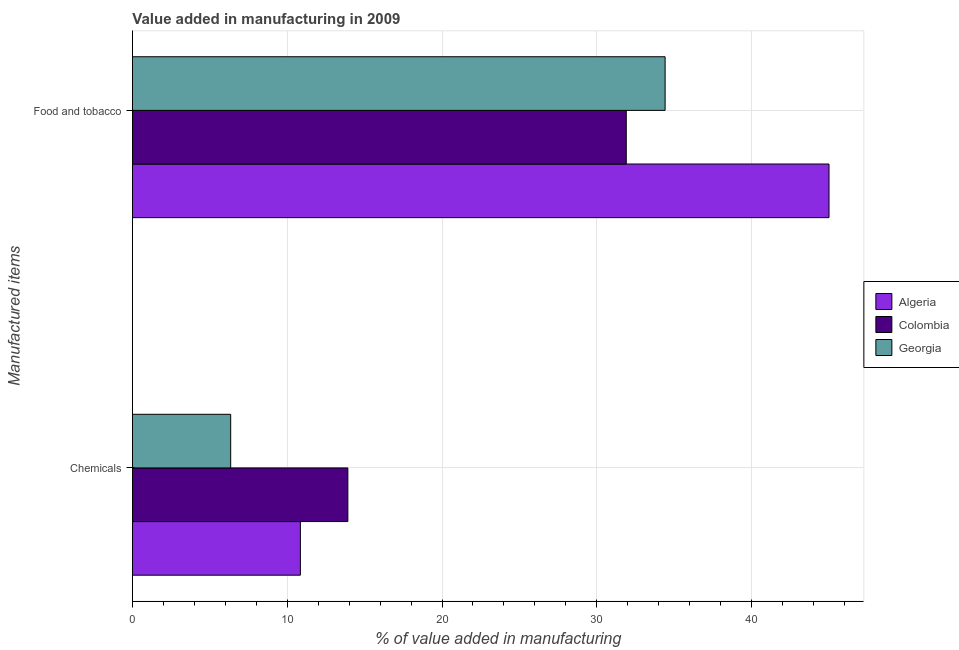How many groups of bars are there?
Keep it short and to the point. 2. Are the number of bars per tick equal to the number of legend labels?
Make the answer very short. Yes. How many bars are there on the 1st tick from the top?
Keep it short and to the point. 3. How many bars are there on the 1st tick from the bottom?
Offer a terse response. 3. What is the label of the 2nd group of bars from the top?
Your answer should be very brief. Chemicals. What is the value added by  manufacturing chemicals in Algeria?
Your response must be concise. 10.85. Across all countries, what is the maximum value added by  manufacturing chemicals?
Provide a short and direct response. 13.92. Across all countries, what is the minimum value added by  manufacturing chemicals?
Your answer should be very brief. 6.35. In which country was the value added by manufacturing food and tobacco maximum?
Your response must be concise. Algeria. What is the total value added by manufacturing food and tobacco in the graph?
Keep it short and to the point. 111.31. What is the difference between the value added by manufacturing food and tobacco in Georgia and that in Algeria?
Keep it short and to the point. -10.59. What is the difference between the value added by  manufacturing chemicals in Georgia and the value added by manufacturing food and tobacco in Algeria?
Make the answer very short. -38.65. What is the average value added by  manufacturing chemicals per country?
Offer a terse response. 10.37. What is the difference between the value added by  manufacturing chemicals and value added by manufacturing food and tobacco in Georgia?
Your answer should be compact. -28.06. In how many countries, is the value added by  manufacturing chemicals greater than 28 %?
Make the answer very short. 0. What is the ratio of the value added by  manufacturing chemicals in Georgia to that in Algeria?
Offer a terse response. 0.59. Is the value added by  manufacturing chemicals in Georgia less than that in Algeria?
Your response must be concise. Yes. What does the 1st bar from the top in Chemicals represents?
Your answer should be very brief. Georgia. What does the 1st bar from the bottom in Chemicals represents?
Offer a terse response. Algeria. How many countries are there in the graph?
Offer a very short reply. 3. Does the graph contain grids?
Your response must be concise. Yes. What is the title of the graph?
Your response must be concise. Value added in manufacturing in 2009. Does "Indonesia" appear as one of the legend labels in the graph?
Provide a succinct answer. No. What is the label or title of the X-axis?
Make the answer very short. % of value added in manufacturing. What is the label or title of the Y-axis?
Give a very brief answer. Manufactured items. What is the % of value added in manufacturing in Algeria in Chemicals?
Your answer should be compact. 10.85. What is the % of value added in manufacturing of Colombia in Chemicals?
Provide a succinct answer. 13.92. What is the % of value added in manufacturing of Georgia in Chemicals?
Keep it short and to the point. 6.35. What is the % of value added in manufacturing of Algeria in Food and tobacco?
Make the answer very short. 45. What is the % of value added in manufacturing of Colombia in Food and tobacco?
Provide a succinct answer. 31.9. What is the % of value added in manufacturing of Georgia in Food and tobacco?
Offer a very short reply. 34.41. Across all Manufactured items, what is the maximum % of value added in manufacturing in Algeria?
Provide a succinct answer. 45. Across all Manufactured items, what is the maximum % of value added in manufacturing of Colombia?
Provide a short and direct response. 31.9. Across all Manufactured items, what is the maximum % of value added in manufacturing in Georgia?
Your answer should be very brief. 34.41. Across all Manufactured items, what is the minimum % of value added in manufacturing in Algeria?
Give a very brief answer. 10.85. Across all Manufactured items, what is the minimum % of value added in manufacturing in Colombia?
Offer a very short reply. 13.92. Across all Manufactured items, what is the minimum % of value added in manufacturing in Georgia?
Make the answer very short. 6.35. What is the total % of value added in manufacturing of Algeria in the graph?
Offer a very short reply. 55.85. What is the total % of value added in manufacturing of Colombia in the graph?
Ensure brevity in your answer.  45.82. What is the total % of value added in manufacturing of Georgia in the graph?
Your answer should be very brief. 40.76. What is the difference between the % of value added in manufacturing in Algeria in Chemicals and that in Food and tobacco?
Make the answer very short. -34.15. What is the difference between the % of value added in manufacturing of Colombia in Chemicals and that in Food and tobacco?
Make the answer very short. -17.98. What is the difference between the % of value added in manufacturing of Georgia in Chemicals and that in Food and tobacco?
Keep it short and to the point. -28.06. What is the difference between the % of value added in manufacturing of Algeria in Chemicals and the % of value added in manufacturing of Colombia in Food and tobacco?
Your response must be concise. -21.05. What is the difference between the % of value added in manufacturing in Algeria in Chemicals and the % of value added in manufacturing in Georgia in Food and tobacco?
Ensure brevity in your answer.  -23.56. What is the difference between the % of value added in manufacturing in Colombia in Chemicals and the % of value added in manufacturing in Georgia in Food and tobacco?
Give a very brief answer. -20.49. What is the average % of value added in manufacturing of Algeria per Manufactured items?
Give a very brief answer. 27.92. What is the average % of value added in manufacturing of Colombia per Manufactured items?
Your answer should be compact. 22.91. What is the average % of value added in manufacturing of Georgia per Manufactured items?
Keep it short and to the point. 20.38. What is the difference between the % of value added in manufacturing in Algeria and % of value added in manufacturing in Colombia in Chemicals?
Make the answer very short. -3.07. What is the difference between the % of value added in manufacturing of Algeria and % of value added in manufacturing of Georgia in Chemicals?
Keep it short and to the point. 4.5. What is the difference between the % of value added in manufacturing of Colombia and % of value added in manufacturing of Georgia in Chemicals?
Offer a very short reply. 7.57. What is the difference between the % of value added in manufacturing of Algeria and % of value added in manufacturing of Colombia in Food and tobacco?
Your answer should be very brief. 13.1. What is the difference between the % of value added in manufacturing in Algeria and % of value added in manufacturing in Georgia in Food and tobacco?
Ensure brevity in your answer.  10.59. What is the difference between the % of value added in manufacturing in Colombia and % of value added in manufacturing in Georgia in Food and tobacco?
Your answer should be very brief. -2.51. What is the ratio of the % of value added in manufacturing in Algeria in Chemicals to that in Food and tobacco?
Your answer should be very brief. 0.24. What is the ratio of the % of value added in manufacturing in Colombia in Chemicals to that in Food and tobacco?
Provide a short and direct response. 0.44. What is the ratio of the % of value added in manufacturing of Georgia in Chemicals to that in Food and tobacco?
Provide a succinct answer. 0.18. What is the difference between the highest and the second highest % of value added in manufacturing in Algeria?
Make the answer very short. 34.15. What is the difference between the highest and the second highest % of value added in manufacturing of Colombia?
Your answer should be compact. 17.98. What is the difference between the highest and the second highest % of value added in manufacturing in Georgia?
Give a very brief answer. 28.06. What is the difference between the highest and the lowest % of value added in manufacturing in Algeria?
Provide a succinct answer. 34.15. What is the difference between the highest and the lowest % of value added in manufacturing in Colombia?
Give a very brief answer. 17.98. What is the difference between the highest and the lowest % of value added in manufacturing of Georgia?
Offer a very short reply. 28.06. 